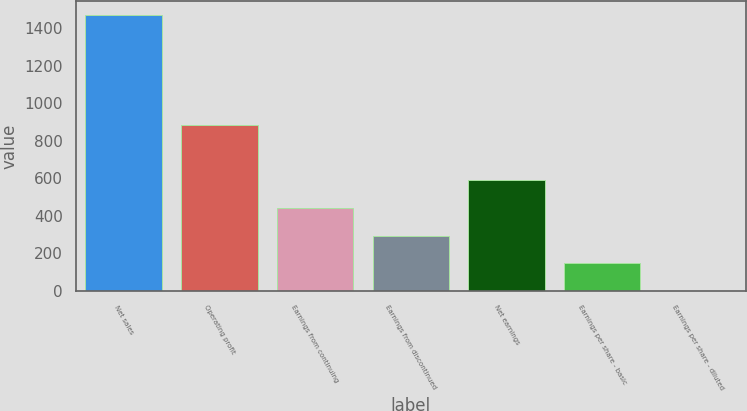Convert chart to OTSL. <chart><loc_0><loc_0><loc_500><loc_500><bar_chart><fcel>Net sales<fcel>Operating profit<fcel>Earnings from continuing<fcel>Earnings from discontinued<fcel>Net earnings<fcel>Earnings per share - basic<fcel>Earnings per share - diluted<nl><fcel>1471<fcel>882.88<fcel>441.76<fcel>294.72<fcel>588.8<fcel>147.68<fcel>0.64<nl></chart> 